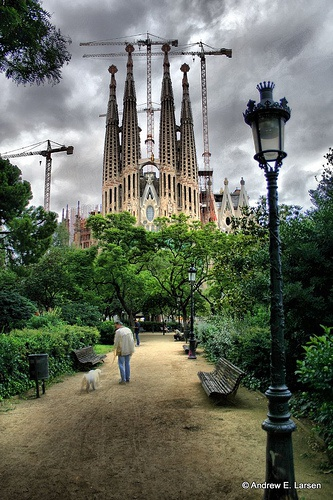Describe the objects in this image and their specific colors. I can see bench in darkgreen, black, gray, and darkgray tones, people in darkgreen, darkgray, gray, and lightgray tones, bench in darkgreen, gray, and black tones, dog in darkgreen, darkgray, and gray tones, and people in darkgreen, black, gray, navy, and darkgray tones in this image. 